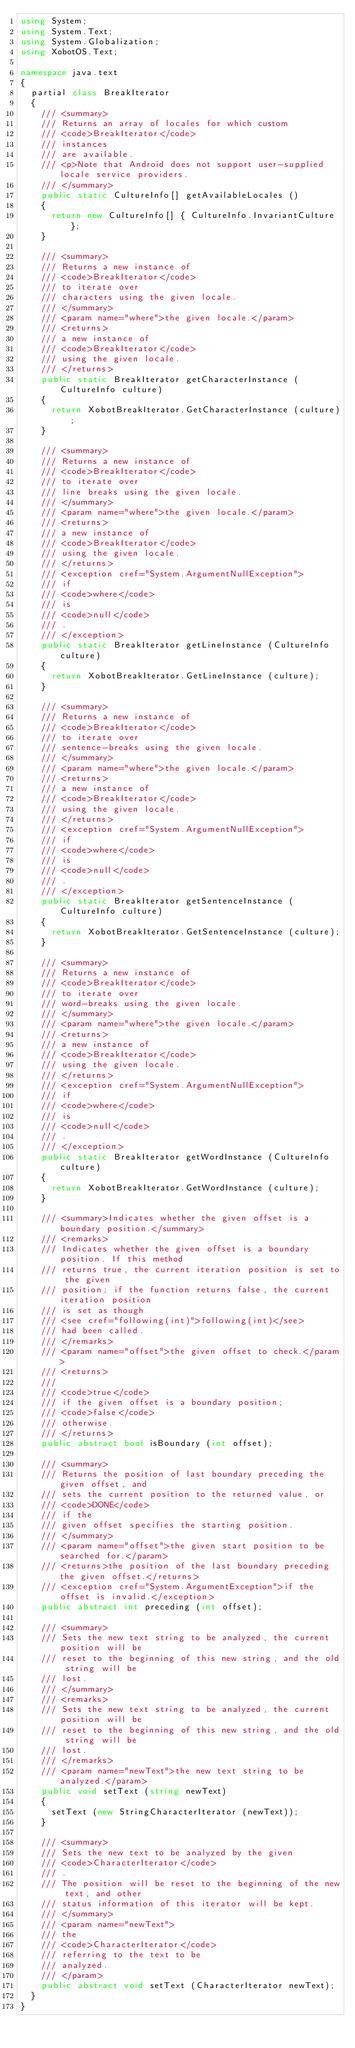Convert code to text. <code><loc_0><loc_0><loc_500><loc_500><_C#_>using System;
using System.Text;
using System.Globalization;
using XobotOS.Text;

namespace java.text
{
	partial class BreakIterator
	{
		/// <summary>
		/// Returns an array of locales for which custom
		/// <code>BreakIterator</code>
		/// instances
		/// are available.
		/// <p>Note that Android does not support user-supplied locale service providers.
		/// </summary>
		public static CultureInfo[] getAvailableLocales ()
		{
			return new CultureInfo[] { CultureInfo.InvariantCulture };
		}

		/// <summary>
		/// Returns a new instance of
		/// <code>BreakIterator</code>
		/// to iterate over
		/// characters using the given locale.
		/// </summary>
		/// <param name="where">the given locale.</param>
		/// <returns>
		/// a new instance of
		/// <code>BreakIterator</code>
		/// using the given locale.
		/// </returns>
		public static BreakIterator getCharacterInstance (CultureInfo culture)
		{
			return XobotBreakIterator.GetCharacterInstance (culture);
		}

		/// <summary>
		/// Returns a new instance of
		/// <code>BreakIterator</code>
		/// to iterate over
		/// line breaks using the given locale.
		/// </summary>
		/// <param name="where">the given locale.</param>
		/// <returns>
		/// a new instance of
		/// <code>BreakIterator</code>
		/// using the given locale.
		/// </returns>
		/// <exception cref="System.ArgumentNullException">
		/// if
		/// <code>where</code>
		/// is
		/// <code>null</code>
		/// .
		/// </exception>
		public static BreakIterator getLineInstance (CultureInfo culture)
		{
			return XobotBreakIterator.GetLineInstance (culture);
		}

		/// <summary>
		/// Returns a new instance of
		/// <code>BreakIterator</code>
		/// to iterate over
		/// sentence-breaks using the given locale.
		/// </summary>
		/// <param name="where">the given locale.</param>
		/// <returns>
		/// a new instance of
		/// <code>BreakIterator</code>
		/// using the given locale.
		/// </returns>
		/// <exception cref="System.ArgumentNullException">
		/// if
		/// <code>where</code>
		/// is
		/// <code>null</code>
		/// .
		/// </exception>
		public static BreakIterator getSentenceInstance (CultureInfo culture)
		{
			return XobotBreakIterator.GetSentenceInstance (culture);
		}

		/// <summary>
		/// Returns a new instance of
		/// <code>BreakIterator</code>
		/// to iterate over
		/// word-breaks using the given locale.
		/// </summary>
		/// <param name="where">the given locale.</param>
		/// <returns>
		/// a new instance of
		/// <code>BreakIterator</code>
		/// using the given locale.
		/// </returns>
		/// <exception cref="System.ArgumentNullException">
		/// if
		/// <code>where</code>
		/// is
		/// <code>null</code>
		/// .
		/// </exception>
		public static BreakIterator getWordInstance (CultureInfo culture)
		{
			return XobotBreakIterator.GetWordInstance (culture);
		}

		/// <summary>Indicates whether the given offset is a boundary position.</summary>
		/// <remarks>
		/// Indicates whether the given offset is a boundary position. If this method
		/// returns true, the current iteration position is set to the given
		/// position; if the function returns false, the current iteration position
		/// is set as though
		/// <see cref="following(int)">following(int)</see>
		/// had been called.
		/// </remarks>
		/// <param name="offset">the given offset to check.</param>
		/// <returns>
		///
		/// <code>true</code>
		/// if the given offset is a boundary position;
		/// <code>false</code>
		/// otherwise.
		/// </returns>
		public abstract bool isBoundary (int offset);

		/// <summary>
		/// Returns the position of last boundary preceding the given offset, and
		/// sets the current position to the returned value, or
		/// <code>DONE</code>
		/// if the
		/// given offset specifies the starting position.
		/// </summary>
		/// <param name="offset">the given start position to be searched for.</param>
		/// <returns>the position of the last boundary preceding the given offset.</returns>
		/// <exception cref="System.ArgumentException">if the offset is invalid.</exception>
		public abstract int preceding (int offset);

		/// <summary>
		/// Sets the new text string to be analyzed, the current position will be
		/// reset to the beginning of this new string, and the old string will be
		/// lost.
		/// </summary>
		/// <remarks>
		/// Sets the new text string to be analyzed, the current position will be
		/// reset to the beginning of this new string, and the old string will be
		/// lost.
		/// </remarks>
		/// <param name="newText">the new text string to be analyzed.</param>
		public void setText (string newText)
		{
			setText (new StringCharacterIterator (newText));
		}

		/// <summary>
		/// Sets the new text to be analyzed by the given
		/// <code>CharacterIterator</code>
		/// .
		/// The position will be reset to the beginning of the new text, and other
		/// status information of this iterator will be kept.
		/// </summary>
		/// <param name="newText">
		/// the
		/// <code>CharacterIterator</code>
		/// referring to the text to be
		/// analyzed.
		/// </param>
		public abstract void setText (CharacterIterator newText);
	}
}

</code> 